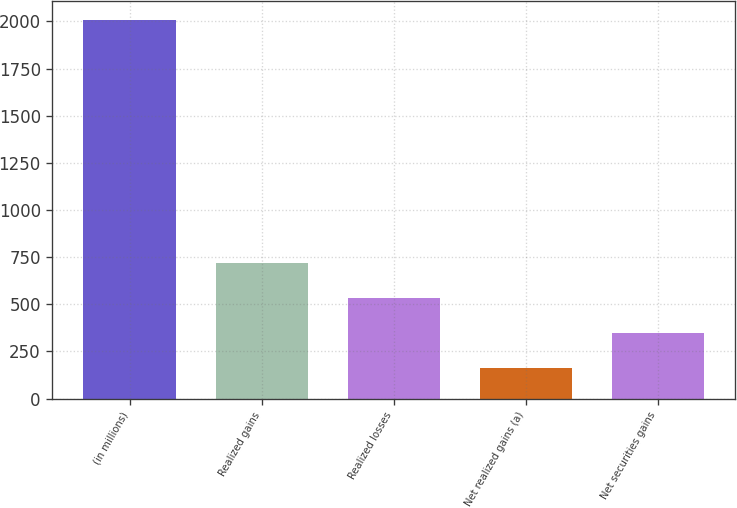Convert chart to OTSL. <chart><loc_0><loc_0><loc_500><loc_500><bar_chart><fcel>(in millions)<fcel>Realized gains<fcel>Realized losses<fcel>Net realized gains (a)<fcel>Net securities gains<nl><fcel>2007<fcel>716.9<fcel>532.6<fcel>164<fcel>348.3<nl></chart> 